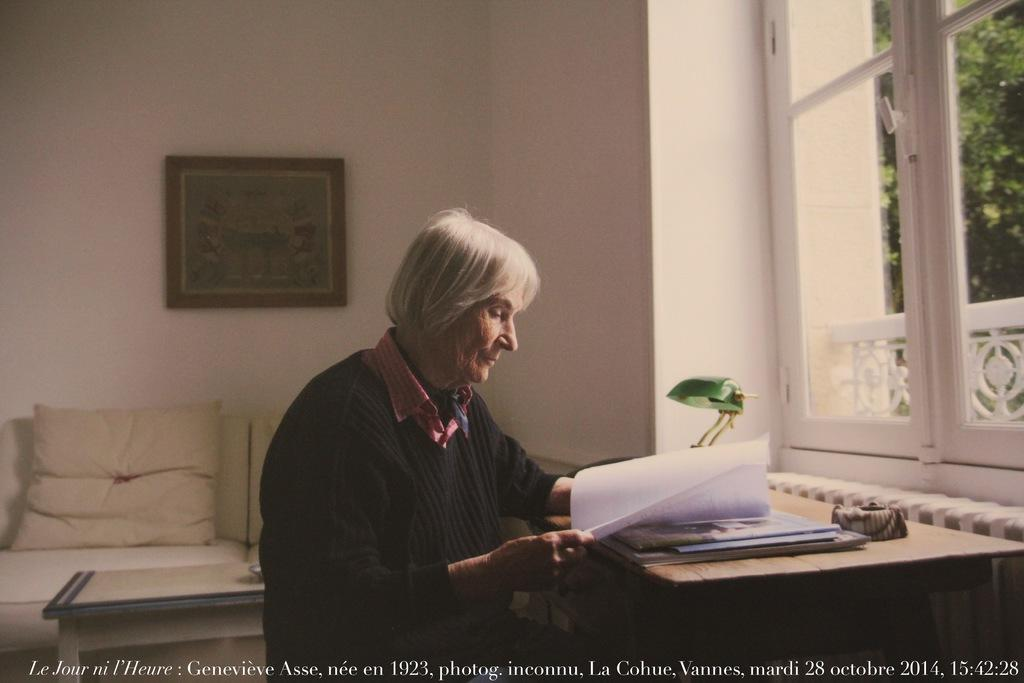Who is present in the image? There is a woman in the image. What is the woman holding? The woman is holding a paper. What can be seen on the table in the image? There is a lamp on the table in the image. What is visible on the wall in the background of the image? There is a frame on the wall in the background of the image. What type of pickle is on the woman's plate in the image? There is no plate or pickle present in the image. What type of lace is visible on the woman's clothing in the image? There is no lace visible on the woman's clothing in the image. 